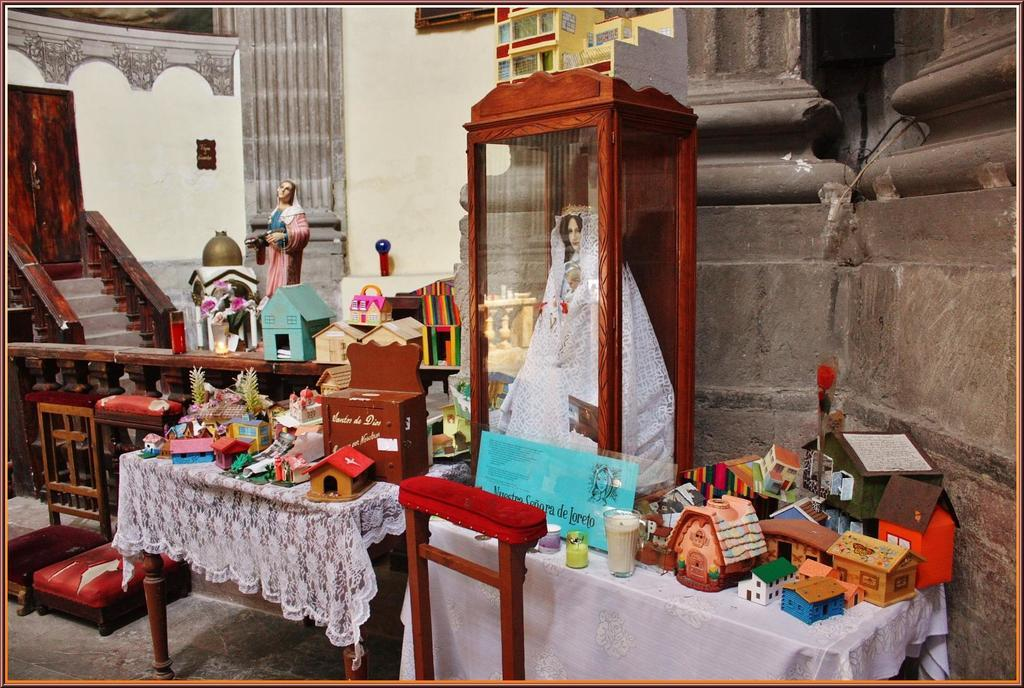What type of furniture is present in the room? There is a table in the room. What is on the table in the room? The table has toys on it. What is on another table in the room? There is a glass box on another table. What is inside the glass box? The glass box contains a woman's sculpture. What else is on the same table as the glass box? There is another person's sculpture on the same table as the glass box. How many pigs are present in the room? There is no mention of pigs in the provided facts, so we cannot determine their presence in the room. What type of hat is the woman's sculpture wearing? The provided facts do not mention any hats, so we cannot determine if the woman's sculpture is wearing a hat. 